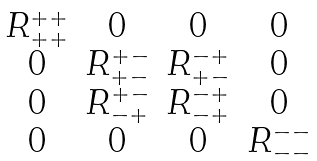<formula> <loc_0><loc_0><loc_500><loc_500>\begin{matrix} R _ { + + } ^ { + + } & 0 & 0 & 0 \\ 0 & R _ { + - } ^ { + - } & R ^ { - + } _ { + - } & 0 \\ 0 & R ^ { + - } _ { - + } & R _ { - + } ^ { - + } & 0 \\ 0 & 0 & 0 & R ^ { - - } _ { - - } \end{matrix}</formula> 